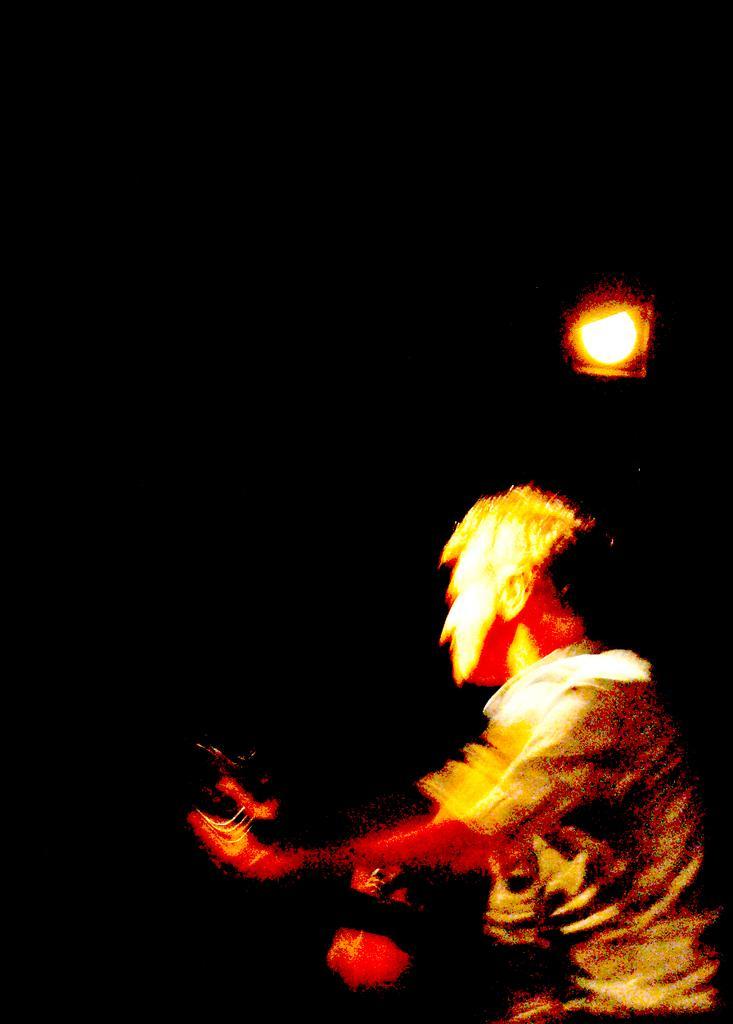Please provide a concise description of this image. A man is there, he wore shirt. At the top there is a light. 